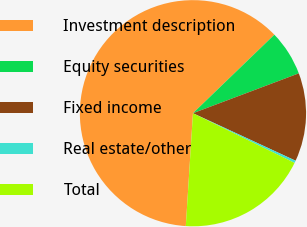Convert chart to OTSL. <chart><loc_0><loc_0><loc_500><loc_500><pie_chart><fcel>Investment description<fcel>Equity securities<fcel>Fixed income<fcel>Real estate/other<fcel>Total<nl><fcel>61.78%<fcel>6.48%<fcel>12.63%<fcel>0.34%<fcel>18.77%<nl></chart> 